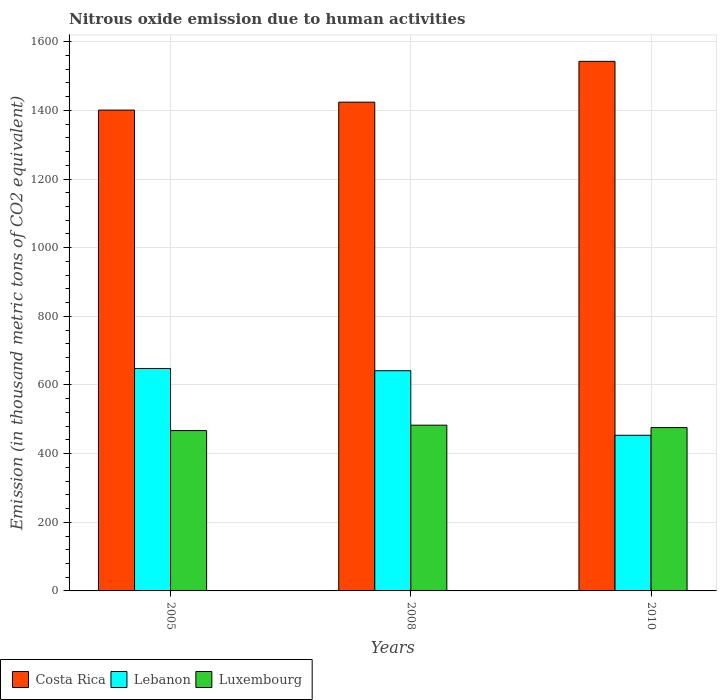How many bars are there on the 2nd tick from the right?
Give a very brief answer. 3. What is the label of the 3rd group of bars from the left?
Offer a terse response. 2010. What is the amount of nitrous oxide emitted in Costa Rica in 2008?
Provide a succinct answer. 1424.1. Across all years, what is the maximum amount of nitrous oxide emitted in Luxembourg?
Keep it short and to the point. 482.9. Across all years, what is the minimum amount of nitrous oxide emitted in Costa Rica?
Keep it short and to the point. 1401. What is the total amount of nitrous oxide emitted in Luxembourg in the graph?
Give a very brief answer. 1426. What is the difference between the amount of nitrous oxide emitted in Luxembourg in 2005 and that in 2008?
Provide a short and direct response. -15.7. What is the difference between the amount of nitrous oxide emitted in Costa Rica in 2008 and the amount of nitrous oxide emitted in Lebanon in 2010?
Provide a succinct answer. 970.6. What is the average amount of nitrous oxide emitted in Costa Rica per year?
Provide a short and direct response. 1456.03. In the year 2010, what is the difference between the amount of nitrous oxide emitted in Luxembourg and amount of nitrous oxide emitted in Lebanon?
Keep it short and to the point. 22.4. In how many years, is the amount of nitrous oxide emitted in Costa Rica greater than 920 thousand metric tons?
Keep it short and to the point. 3. What is the ratio of the amount of nitrous oxide emitted in Lebanon in 2005 to that in 2010?
Offer a very short reply. 1.43. Is the difference between the amount of nitrous oxide emitted in Luxembourg in 2005 and 2008 greater than the difference between the amount of nitrous oxide emitted in Lebanon in 2005 and 2008?
Your answer should be compact. No. What is the difference between the highest and the second highest amount of nitrous oxide emitted in Costa Rica?
Keep it short and to the point. 118.9. What is the difference between the highest and the lowest amount of nitrous oxide emitted in Costa Rica?
Keep it short and to the point. 142. Is the sum of the amount of nitrous oxide emitted in Lebanon in 2005 and 2008 greater than the maximum amount of nitrous oxide emitted in Costa Rica across all years?
Keep it short and to the point. No. What does the 1st bar from the left in 2005 represents?
Make the answer very short. Costa Rica. What does the 2nd bar from the right in 2008 represents?
Ensure brevity in your answer.  Lebanon. How many bars are there?
Your response must be concise. 9. Are all the bars in the graph horizontal?
Make the answer very short. No. How many years are there in the graph?
Your answer should be very brief. 3. What is the difference between two consecutive major ticks on the Y-axis?
Your answer should be very brief. 200. Are the values on the major ticks of Y-axis written in scientific E-notation?
Provide a short and direct response. No. Does the graph contain grids?
Your response must be concise. Yes. How are the legend labels stacked?
Offer a terse response. Horizontal. What is the title of the graph?
Your response must be concise. Nitrous oxide emission due to human activities. Does "Antigua and Barbuda" appear as one of the legend labels in the graph?
Provide a succinct answer. No. What is the label or title of the X-axis?
Make the answer very short. Years. What is the label or title of the Y-axis?
Your response must be concise. Emission (in thousand metric tons of CO2 equivalent). What is the Emission (in thousand metric tons of CO2 equivalent) in Costa Rica in 2005?
Ensure brevity in your answer.  1401. What is the Emission (in thousand metric tons of CO2 equivalent) of Lebanon in 2005?
Your answer should be very brief. 648. What is the Emission (in thousand metric tons of CO2 equivalent) of Luxembourg in 2005?
Offer a terse response. 467.2. What is the Emission (in thousand metric tons of CO2 equivalent) in Costa Rica in 2008?
Your answer should be compact. 1424.1. What is the Emission (in thousand metric tons of CO2 equivalent) of Lebanon in 2008?
Keep it short and to the point. 641.6. What is the Emission (in thousand metric tons of CO2 equivalent) in Luxembourg in 2008?
Offer a very short reply. 482.9. What is the Emission (in thousand metric tons of CO2 equivalent) of Costa Rica in 2010?
Offer a terse response. 1543. What is the Emission (in thousand metric tons of CO2 equivalent) of Lebanon in 2010?
Make the answer very short. 453.5. What is the Emission (in thousand metric tons of CO2 equivalent) in Luxembourg in 2010?
Ensure brevity in your answer.  475.9. Across all years, what is the maximum Emission (in thousand metric tons of CO2 equivalent) in Costa Rica?
Give a very brief answer. 1543. Across all years, what is the maximum Emission (in thousand metric tons of CO2 equivalent) in Lebanon?
Provide a succinct answer. 648. Across all years, what is the maximum Emission (in thousand metric tons of CO2 equivalent) of Luxembourg?
Offer a terse response. 482.9. Across all years, what is the minimum Emission (in thousand metric tons of CO2 equivalent) of Costa Rica?
Offer a very short reply. 1401. Across all years, what is the minimum Emission (in thousand metric tons of CO2 equivalent) in Lebanon?
Make the answer very short. 453.5. Across all years, what is the minimum Emission (in thousand metric tons of CO2 equivalent) in Luxembourg?
Give a very brief answer. 467.2. What is the total Emission (in thousand metric tons of CO2 equivalent) in Costa Rica in the graph?
Keep it short and to the point. 4368.1. What is the total Emission (in thousand metric tons of CO2 equivalent) of Lebanon in the graph?
Offer a terse response. 1743.1. What is the total Emission (in thousand metric tons of CO2 equivalent) in Luxembourg in the graph?
Offer a terse response. 1426. What is the difference between the Emission (in thousand metric tons of CO2 equivalent) in Costa Rica in 2005 and that in 2008?
Provide a short and direct response. -23.1. What is the difference between the Emission (in thousand metric tons of CO2 equivalent) in Lebanon in 2005 and that in 2008?
Make the answer very short. 6.4. What is the difference between the Emission (in thousand metric tons of CO2 equivalent) of Luxembourg in 2005 and that in 2008?
Provide a short and direct response. -15.7. What is the difference between the Emission (in thousand metric tons of CO2 equivalent) in Costa Rica in 2005 and that in 2010?
Provide a succinct answer. -142. What is the difference between the Emission (in thousand metric tons of CO2 equivalent) of Lebanon in 2005 and that in 2010?
Make the answer very short. 194.5. What is the difference between the Emission (in thousand metric tons of CO2 equivalent) of Luxembourg in 2005 and that in 2010?
Provide a succinct answer. -8.7. What is the difference between the Emission (in thousand metric tons of CO2 equivalent) of Costa Rica in 2008 and that in 2010?
Ensure brevity in your answer.  -118.9. What is the difference between the Emission (in thousand metric tons of CO2 equivalent) in Lebanon in 2008 and that in 2010?
Your answer should be compact. 188.1. What is the difference between the Emission (in thousand metric tons of CO2 equivalent) in Luxembourg in 2008 and that in 2010?
Provide a short and direct response. 7. What is the difference between the Emission (in thousand metric tons of CO2 equivalent) in Costa Rica in 2005 and the Emission (in thousand metric tons of CO2 equivalent) in Lebanon in 2008?
Make the answer very short. 759.4. What is the difference between the Emission (in thousand metric tons of CO2 equivalent) in Costa Rica in 2005 and the Emission (in thousand metric tons of CO2 equivalent) in Luxembourg in 2008?
Offer a very short reply. 918.1. What is the difference between the Emission (in thousand metric tons of CO2 equivalent) in Lebanon in 2005 and the Emission (in thousand metric tons of CO2 equivalent) in Luxembourg in 2008?
Provide a succinct answer. 165.1. What is the difference between the Emission (in thousand metric tons of CO2 equivalent) of Costa Rica in 2005 and the Emission (in thousand metric tons of CO2 equivalent) of Lebanon in 2010?
Give a very brief answer. 947.5. What is the difference between the Emission (in thousand metric tons of CO2 equivalent) of Costa Rica in 2005 and the Emission (in thousand metric tons of CO2 equivalent) of Luxembourg in 2010?
Provide a succinct answer. 925.1. What is the difference between the Emission (in thousand metric tons of CO2 equivalent) in Lebanon in 2005 and the Emission (in thousand metric tons of CO2 equivalent) in Luxembourg in 2010?
Ensure brevity in your answer.  172.1. What is the difference between the Emission (in thousand metric tons of CO2 equivalent) in Costa Rica in 2008 and the Emission (in thousand metric tons of CO2 equivalent) in Lebanon in 2010?
Make the answer very short. 970.6. What is the difference between the Emission (in thousand metric tons of CO2 equivalent) of Costa Rica in 2008 and the Emission (in thousand metric tons of CO2 equivalent) of Luxembourg in 2010?
Keep it short and to the point. 948.2. What is the difference between the Emission (in thousand metric tons of CO2 equivalent) of Lebanon in 2008 and the Emission (in thousand metric tons of CO2 equivalent) of Luxembourg in 2010?
Provide a short and direct response. 165.7. What is the average Emission (in thousand metric tons of CO2 equivalent) of Costa Rica per year?
Your response must be concise. 1456.03. What is the average Emission (in thousand metric tons of CO2 equivalent) of Lebanon per year?
Offer a terse response. 581.03. What is the average Emission (in thousand metric tons of CO2 equivalent) in Luxembourg per year?
Make the answer very short. 475.33. In the year 2005, what is the difference between the Emission (in thousand metric tons of CO2 equivalent) in Costa Rica and Emission (in thousand metric tons of CO2 equivalent) in Lebanon?
Provide a short and direct response. 753. In the year 2005, what is the difference between the Emission (in thousand metric tons of CO2 equivalent) in Costa Rica and Emission (in thousand metric tons of CO2 equivalent) in Luxembourg?
Offer a terse response. 933.8. In the year 2005, what is the difference between the Emission (in thousand metric tons of CO2 equivalent) of Lebanon and Emission (in thousand metric tons of CO2 equivalent) of Luxembourg?
Your answer should be compact. 180.8. In the year 2008, what is the difference between the Emission (in thousand metric tons of CO2 equivalent) of Costa Rica and Emission (in thousand metric tons of CO2 equivalent) of Lebanon?
Your answer should be compact. 782.5. In the year 2008, what is the difference between the Emission (in thousand metric tons of CO2 equivalent) of Costa Rica and Emission (in thousand metric tons of CO2 equivalent) of Luxembourg?
Your response must be concise. 941.2. In the year 2008, what is the difference between the Emission (in thousand metric tons of CO2 equivalent) in Lebanon and Emission (in thousand metric tons of CO2 equivalent) in Luxembourg?
Your answer should be very brief. 158.7. In the year 2010, what is the difference between the Emission (in thousand metric tons of CO2 equivalent) in Costa Rica and Emission (in thousand metric tons of CO2 equivalent) in Lebanon?
Offer a terse response. 1089.5. In the year 2010, what is the difference between the Emission (in thousand metric tons of CO2 equivalent) in Costa Rica and Emission (in thousand metric tons of CO2 equivalent) in Luxembourg?
Keep it short and to the point. 1067.1. In the year 2010, what is the difference between the Emission (in thousand metric tons of CO2 equivalent) of Lebanon and Emission (in thousand metric tons of CO2 equivalent) of Luxembourg?
Your answer should be compact. -22.4. What is the ratio of the Emission (in thousand metric tons of CO2 equivalent) of Costa Rica in 2005 to that in 2008?
Give a very brief answer. 0.98. What is the ratio of the Emission (in thousand metric tons of CO2 equivalent) in Lebanon in 2005 to that in 2008?
Ensure brevity in your answer.  1.01. What is the ratio of the Emission (in thousand metric tons of CO2 equivalent) of Luxembourg in 2005 to that in 2008?
Offer a terse response. 0.97. What is the ratio of the Emission (in thousand metric tons of CO2 equivalent) in Costa Rica in 2005 to that in 2010?
Offer a terse response. 0.91. What is the ratio of the Emission (in thousand metric tons of CO2 equivalent) of Lebanon in 2005 to that in 2010?
Ensure brevity in your answer.  1.43. What is the ratio of the Emission (in thousand metric tons of CO2 equivalent) in Luxembourg in 2005 to that in 2010?
Provide a short and direct response. 0.98. What is the ratio of the Emission (in thousand metric tons of CO2 equivalent) in Costa Rica in 2008 to that in 2010?
Provide a short and direct response. 0.92. What is the ratio of the Emission (in thousand metric tons of CO2 equivalent) of Lebanon in 2008 to that in 2010?
Ensure brevity in your answer.  1.41. What is the ratio of the Emission (in thousand metric tons of CO2 equivalent) in Luxembourg in 2008 to that in 2010?
Offer a terse response. 1.01. What is the difference between the highest and the second highest Emission (in thousand metric tons of CO2 equivalent) of Costa Rica?
Offer a very short reply. 118.9. What is the difference between the highest and the second highest Emission (in thousand metric tons of CO2 equivalent) of Luxembourg?
Your response must be concise. 7. What is the difference between the highest and the lowest Emission (in thousand metric tons of CO2 equivalent) of Costa Rica?
Ensure brevity in your answer.  142. What is the difference between the highest and the lowest Emission (in thousand metric tons of CO2 equivalent) of Lebanon?
Offer a terse response. 194.5. 